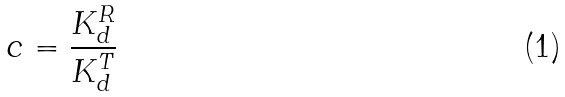Convert formula to latex. <formula><loc_0><loc_0><loc_500><loc_500>c = \frac { K _ { d } ^ { R } } { K _ { d } ^ { T } }</formula> 